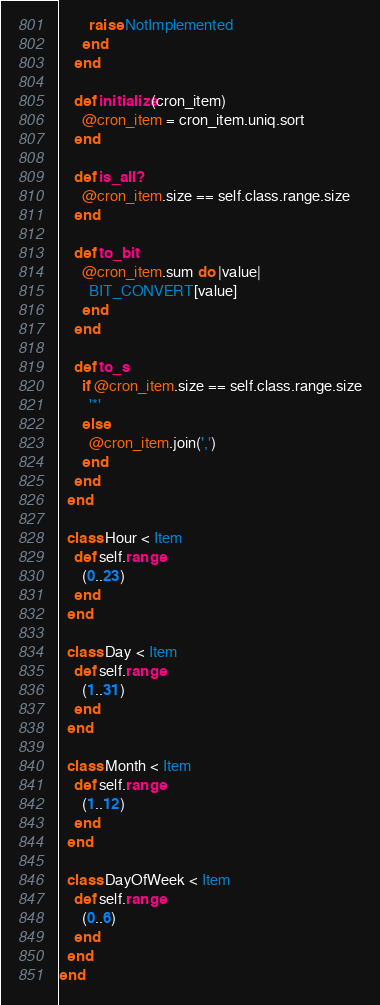<code> <loc_0><loc_0><loc_500><loc_500><_Ruby_>        raise NotImplemented
      end
    end

    def initialize(cron_item)
      @cron_item = cron_item.uniq.sort
    end

    def is_all?
      @cron_item.size == self.class.range.size
    end

    def to_bit
      @cron_item.sum do |value|
        BIT_CONVERT[value]
      end
    end

    def to_s
      if @cron_item.size == self.class.range.size
        '*'
      else
        @cron_item.join(',')
      end
    end
  end

  class Hour < Item
    def self.range
      (0..23)
    end
  end

  class Day < Item
    def self.range
      (1..31)
    end
  end

  class Month < Item
    def self.range
      (1..12)
    end
  end

  class DayOfWeek < Item
    def self.range
      (0..6)
    end
  end
end
</code> 